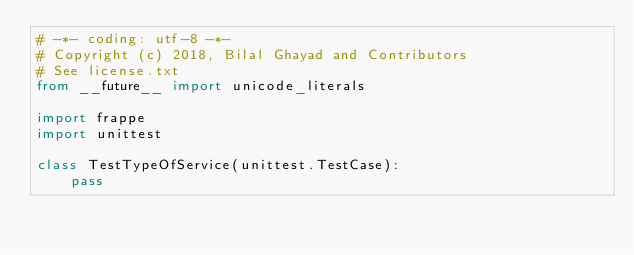Convert code to text. <code><loc_0><loc_0><loc_500><loc_500><_Python_># -*- coding: utf-8 -*-
# Copyright (c) 2018, Bilal Ghayad and Contributors
# See license.txt
from __future__ import unicode_literals

import frappe
import unittest

class TestTypeOfService(unittest.TestCase):
	pass
</code> 